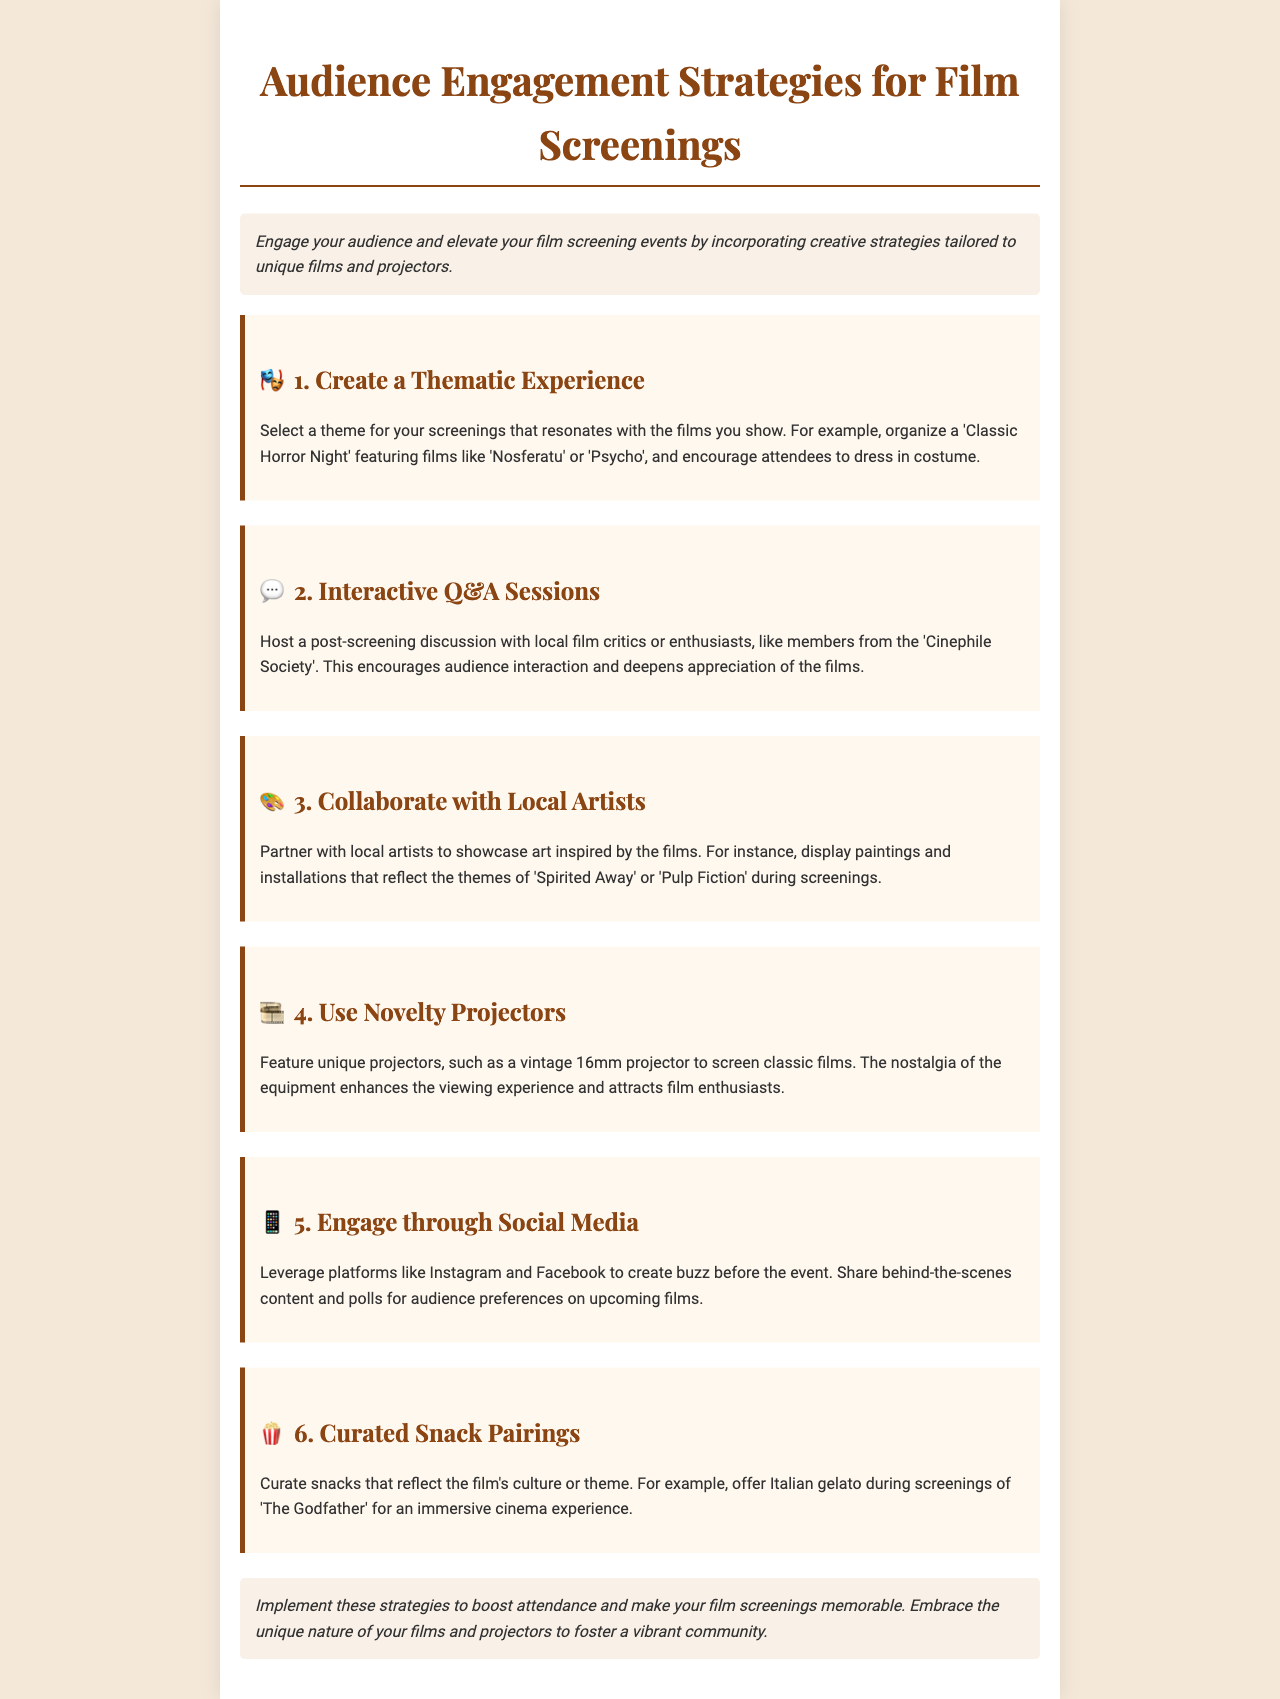What is the title of the document? The title can be found prominently at the top of the document, which indicates the main focus of the content.
Answer: Audience Engagement Strategies for Film Screenings What is one thematic experience suggested? The document outlines various audience engagement strategies, including specific thematic experiences that can enhance screenings.
Answer: Classic Horror Night Which local group is mentioned for interactive sessions? A local film group is suggested for hosting post-screening discussions, promoting audience interaction.
Answer: Cinephile Society What type of projector is recommended? The document advises using a specific type of projector to enhance the film-viewing experience.
Answer: Vintage 16mm projector What should be curated alongside the films? The document emphasizes a complimentary aspect of the film screenings that enhances the overall experience for attendees.
Answer: Snack Pairings How should social media be utilized? The document discusses a method for creating pre-event excitement and engagement with potential attendees.
Answer: Create buzz What is the theme of collaboration suggested in the document? The document encourages working with a specific community to enrich the film screenings experience beyond just the films themselves.
Answer: Local Artists What is the intended outcome of implementing the strategies? The conclusion summarizes the main goal of applying the discussed strategies in the document.
Answer: Boost attendance 